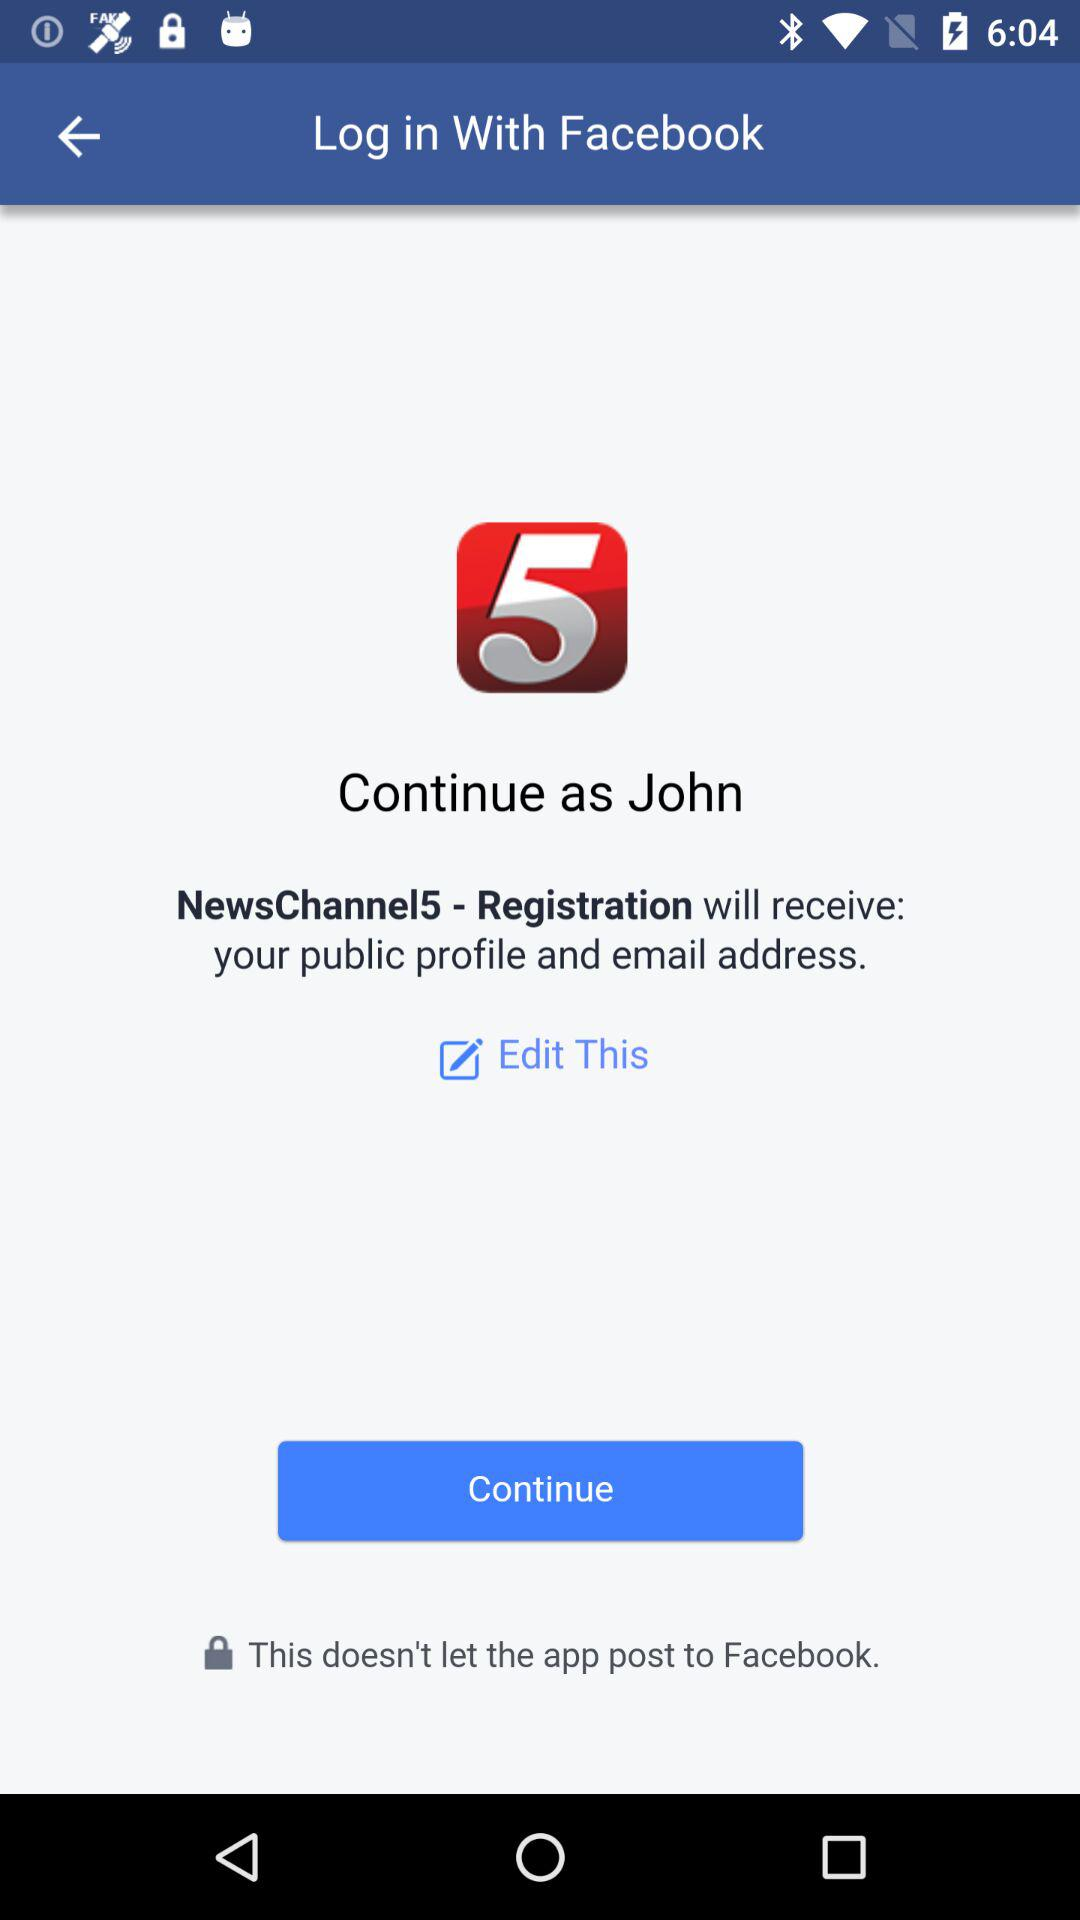What is the user name? The user name is John. 